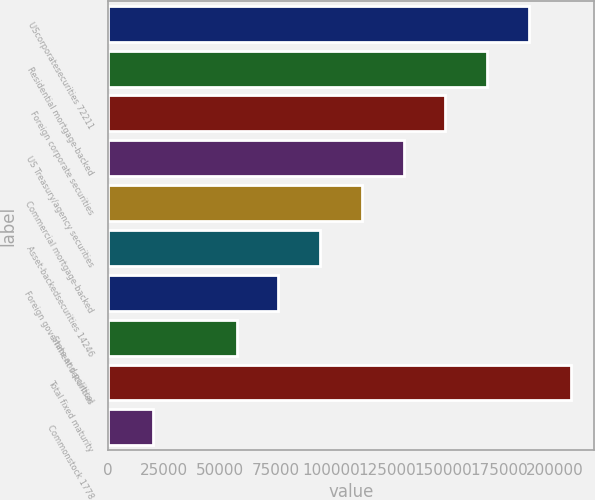Convert chart to OTSL. <chart><loc_0><loc_0><loc_500><loc_500><bar_chart><fcel>UScorporatesecurities 72211<fcel>Residential mortgage-backed<fcel>Foreign corporate securities<fcel>US Treasury/agency securities<fcel>Commercial mortgage-backed<fcel>Asset-backedsecurities 14246<fcel>Foreign government securities<fcel>State and political<fcel>Total fixed maturity<fcel>Commonstock 1778<nl><fcel>188251<fcel>169577<fcel>150903<fcel>132229<fcel>113555<fcel>94881.5<fcel>76207.6<fcel>57533.7<fcel>206925<fcel>20185.9<nl></chart> 